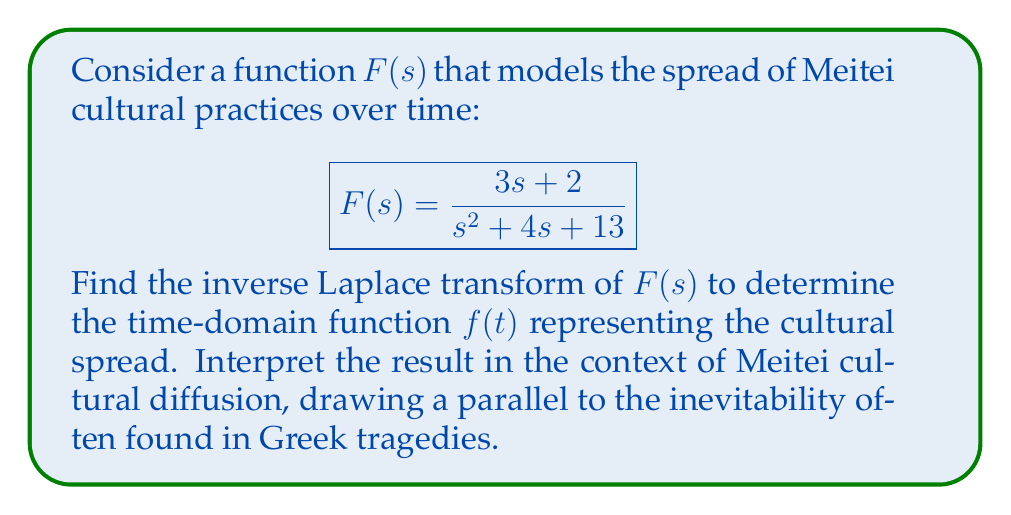Can you solve this math problem? To find the inverse Laplace transform of $F(s)$, we'll follow these steps:

1) First, we need to rewrite $F(s)$ in a form suitable for inverse Laplace transform:

   $$F(s) = \frac{3s + 2}{s^2 + 4s + 13} = \frac{3s}{s^2 + 4s + 13} + \frac{2}{s^2 + 4s + 13}$$

2) Now, we can recognize that this is in the form of:

   $$\frac{as + b}{(s + p)^2 + q^2}$$

   where $a = 3$, $b = 2$, $p = 2$, and $q = 3$.

3) The inverse Laplace transform of this form is:

   $$\mathcal{L}^{-1}\left\{\frac{as + b}{(s + p)^2 + q^2}\right\} = e^{-pt}(a\cos(qt) + \frac{ap + b}{q}\sin(qt))$$

4) Substituting our values:

   $$f(t) = e^{-2t}(3\cos(3t) + \frac{3(2) + 2}{3}\sin(3t))$$

5) Simplifying:

   $$f(t) = e^{-2t}(3\cos(3t) + \frac{8}{3}\sin(3t))$$

This function represents the spread of Meitei cultural practices over time. The exponential decay term $e^{-2t}$ suggests that the rate of spread decreases over time, while the oscillatory terms $\cos(3t)$ and $\sin(3t)$ indicate periodic fluctuations in the spread.

In the context of Meitei cultural diffusion, this could be interpreted as an initial rapid spread of cultural practices, followed by periods of growth and decline, but with an overall trend of stabilization. This pattern mirrors the inevitability often found in Greek tragedies, where characters may struggle against their fate (represented by the oscillations) but ultimately cannot escape it (represented by the exponential decay towards a stable state).
Answer: $$f(t) = e^{-2t}(3\cos(3t) + \frac{8}{3}\sin(3t))$$ 